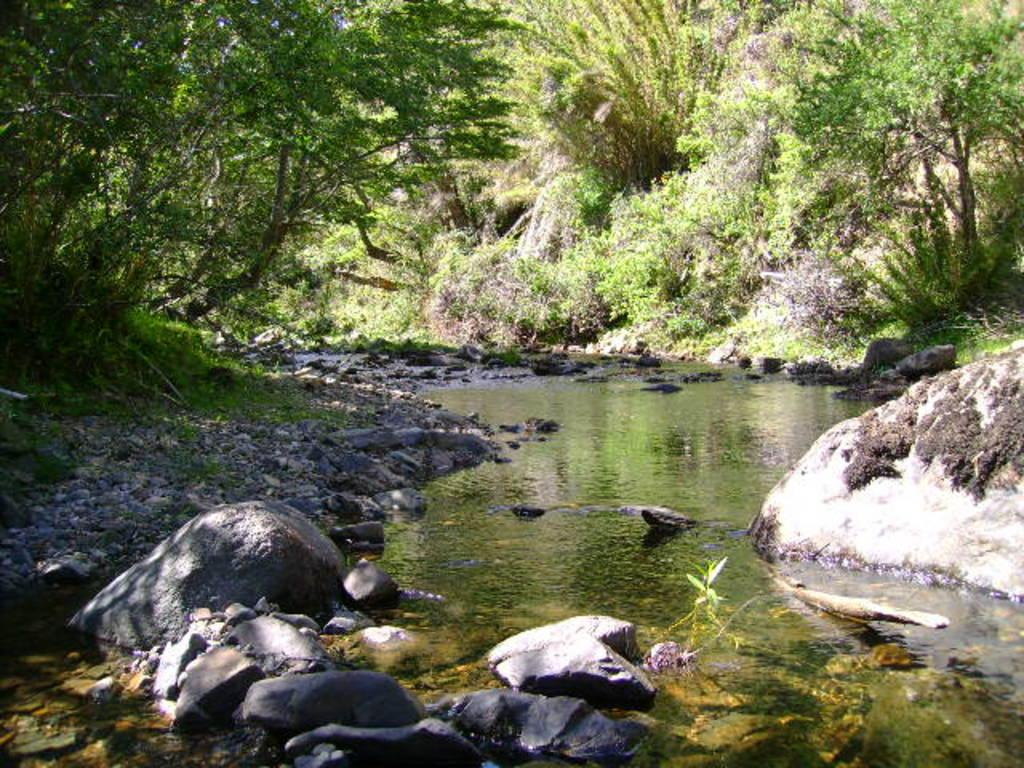What type of natural elements can be seen in the image? There are stones and water visible in the image. What can be seen in the background of the image? There are trees in the background of the image. What type of appliance is connected to the stones in the image? There is no appliance connected to the stones in the image; it is a natural scene with stones and water. 